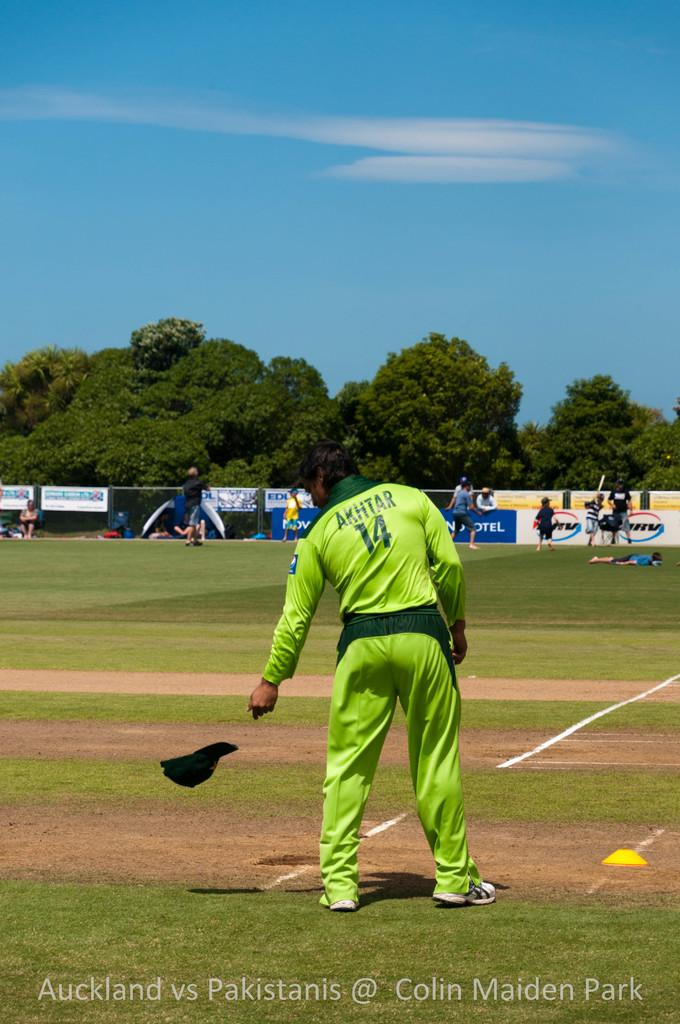Provide a one-sentence caption for the provided image. AKHTAR in the number 14 uniform stands on the field during the Auckland vs Pakistanis game at Colin Maiden Park. 